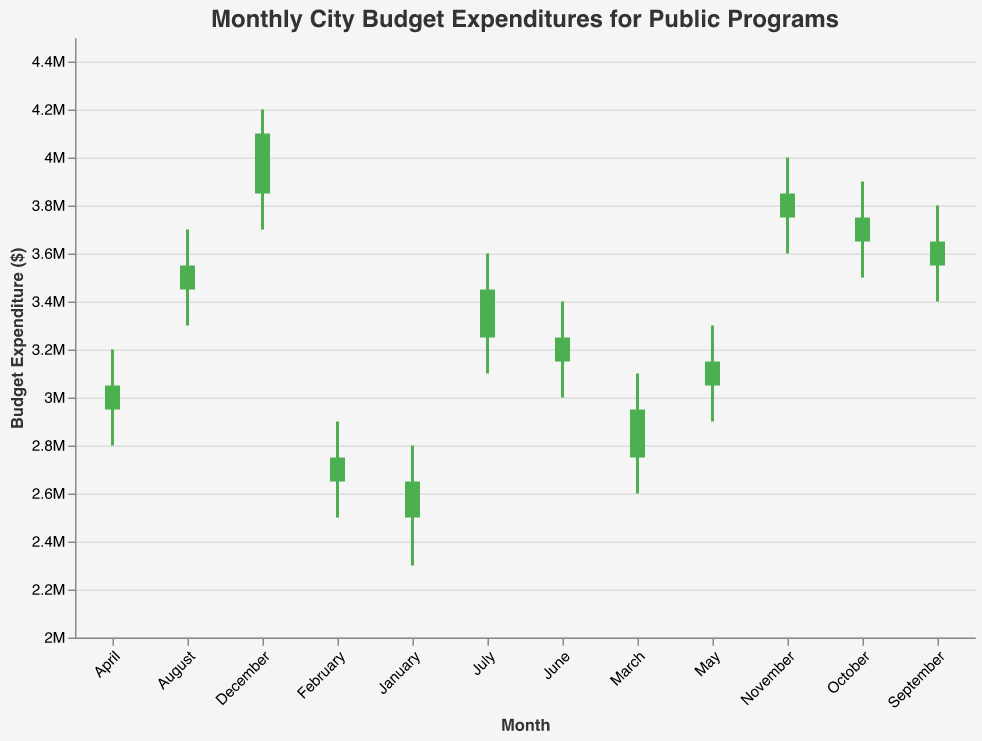What is the title of the chart? The title is usually located at the top of the chart and indicates what the data represents. In this chart, the title is clearly visible.
Answer: Monthly City Budget Expenditures for Public Programs What is the budget expenditure range on the Y-axis? To determine the budget expenditure range, we look at the minimum and maximum values on the Y-axis. These values are usually indicated by tick marks on the Y-axis. In this case, the range is from $2,000,000 to $4,500,000.
Answer: $2,000,000 to $4,500,000 Which month had the highest budget expenditure? The highest budget expenditure is indicated by the highest "Close" value in the OHLC chart. For December, the "Close" value is $4,100,000, which is the highest among all months.
Answer: December Which months had an increase in budget expenditure compared to the previous month? To find the months with increased expenditure, compare each month's "Open" and "Close" values. If "Close" is higher than "Open," expenditure increased. For February to December, each "Close" is higher than the previous month's "Close."
Answer: February to December What is the average "High" value for the last three months of the year? Add the "High" values for October, November, and December, then divide by 3. The "High" values are $3,900,000, $4,000,000, and $4,200,000 respectively. (3,900,000 + 4,000,000 + 4,200,000) / 3 = 4,033,333.33
Answer: $4,033,333.33 Compare the budget expenditures between January and December. Which month had a higher "Low" value? Compare the "Low" values for January and December. January has a "Low" of $2,300,000, while December has a "Low" of $3,700,000. December's "Low" value is higher.
Answer: December Did any month have a "Close" value lower than its "Open" value? Review if there is any month where the "Close" value is less than the "Open" value. All "Close" values are higher than their respective "Open" values, so no month experienced a decrease.
Answer: No What is the difference between the "High" and "Low" values in July? Subtract the "Low" value from the "High" value for July. The "High" is $3,600,000 and the "Low" is $3,100,000. The difference is $500,000.
Answer: $500,000 